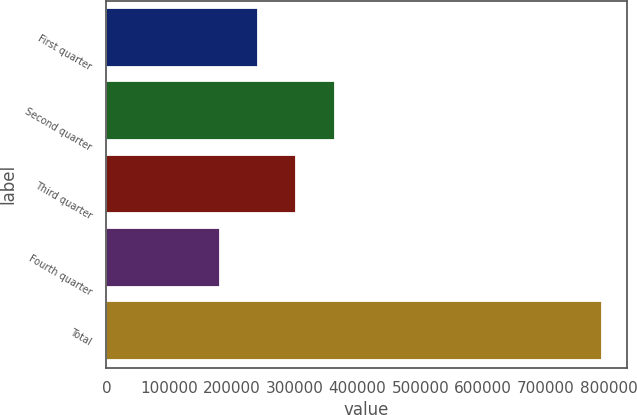Convert chart. <chart><loc_0><loc_0><loc_500><loc_500><bar_chart><fcel>First quarter<fcel>Second quarter<fcel>Third quarter<fcel>Fourth quarter<fcel>Total<nl><fcel>241713<fcel>363494<fcel>302603<fcel>180822<fcel>789729<nl></chart> 